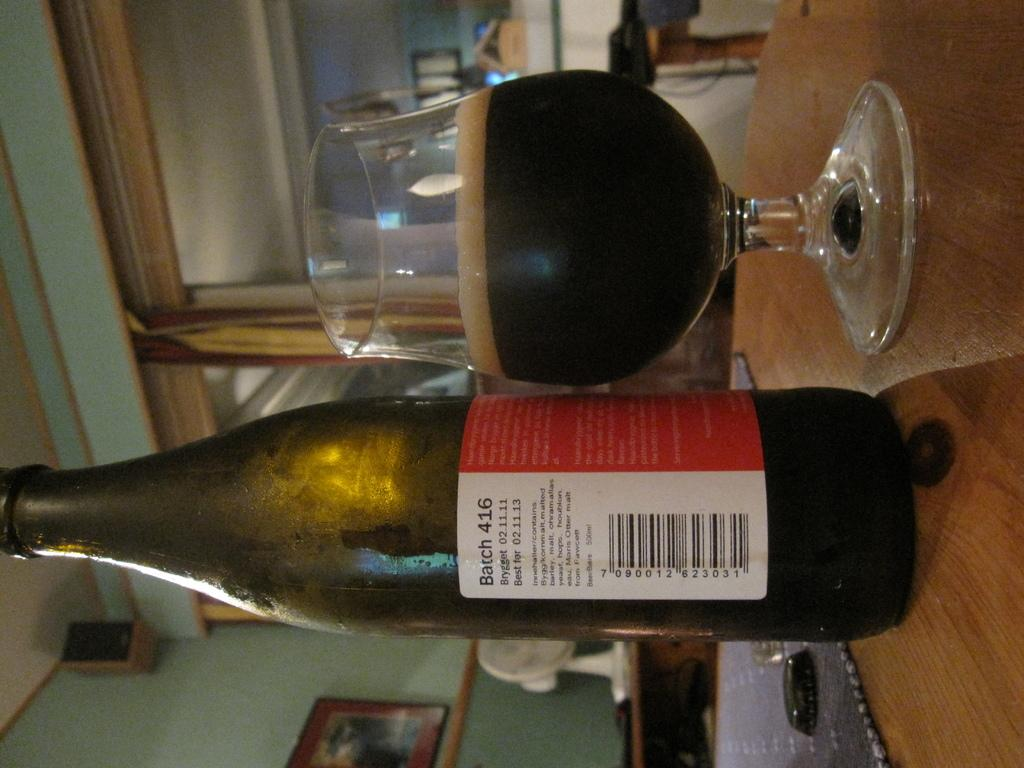<image>
Describe the image concisely. Alcohol bottle which says the batch is 416. 